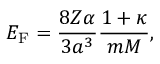Convert formula to latex. <formula><loc_0><loc_0><loc_500><loc_500>E _ { F } = \frac { 8 Z \alpha } { 3 a ^ { 3 } } \frac { 1 + \kappa } { m M } ,</formula> 